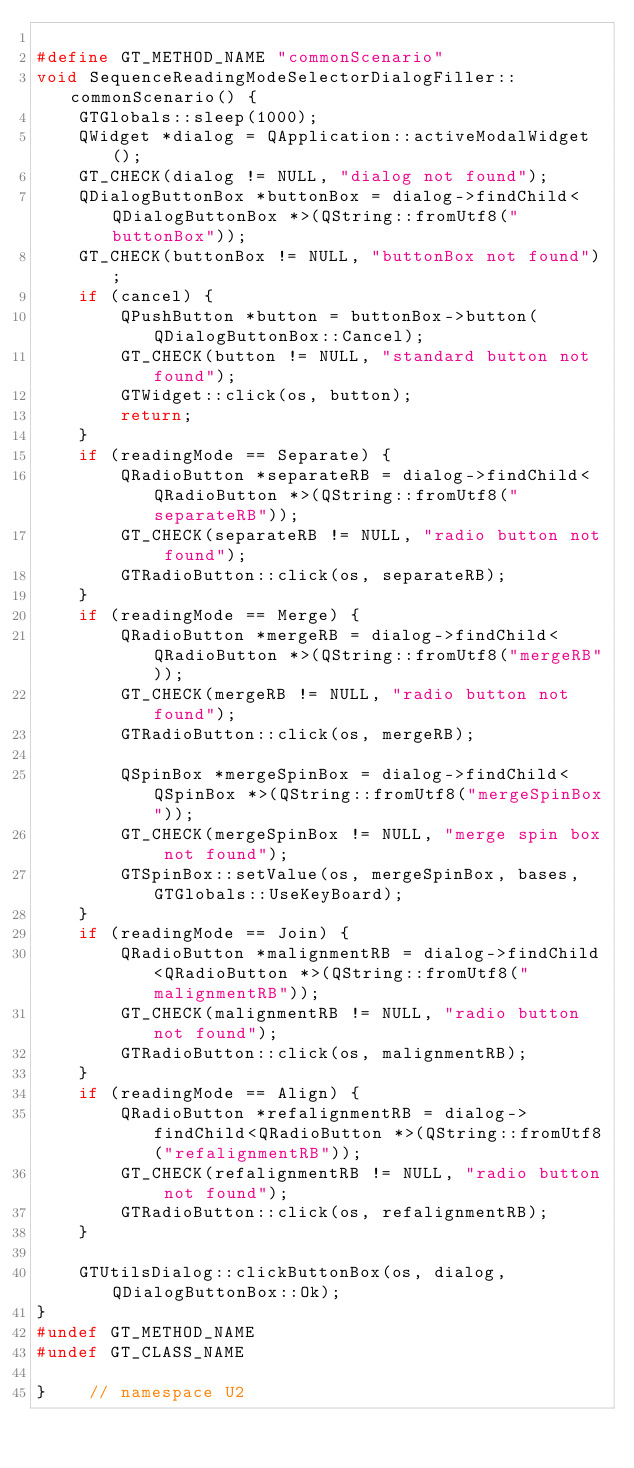Convert code to text. <code><loc_0><loc_0><loc_500><loc_500><_C++_>
#define GT_METHOD_NAME "commonScenario"
void SequenceReadingModeSelectorDialogFiller::commonScenario() {
    GTGlobals::sleep(1000);
    QWidget *dialog = QApplication::activeModalWidget();
    GT_CHECK(dialog != NULL, "dialog not found");
    QDialogButtonBox *buttonBox = dialog->findChild<QDialogButtonBox *>(QString::fromUtf8("buttonBox"));
    GT_CHECK(buttonBox != NULL, "buttonBox not found");
    if (cancel) {
        QPushButton *button = buttonBox->button(QDialogButtonBox::Cancel);
        GT_CHECK(button != NULL, "standard button not found");
        GTWidget::click(os, button);
        return;
    }
    if (readingMode == Separate) {
        QRadioButton *separateRB = dialog->findChild<QRadioButton *>(QString::fromUtf8("separateRB"));
        GT_CHECK(separateRB != NULL, "radio button not found");
        GTRadioButton::click(os, separateRB);
    }
    if (readingMode == Merge) {
        QRadioButton *mergeRB = dialog->findChild<QRadioButton *>(QString::fromUtf8("mergeRB"));
        GT_CHECK(mergeRB != NULL, "radio button not found");
        GTRadioButton::click(os, mergeRB);

        QSpinBox *mergeSpinBox = dialog->findChild<QSpinBox *>(QString::fromUtf8("mergeSpinBox"));
        GT_CHECK(mergeSpinBox != NULL, "merge spin box not found");
        GTSpinBox::setValue(os, mergeSpinBox, bases, GTGlobals::UseKeyBoard);
    }
    if (readingMode == Join) {
        QRadioButton *malignmentRB = dialog->findChild<QRadioButton *>(QString::fromUtf8("malignmentRB"));
        GT_CHECK(malignmentRB != NULL, "radio button not found");
        GTRadioButton::click(os, malignmentRB);
    }
    if (readingMode == Align) {
        QRadioButton *refalignmentRB = dialog->findChild<QRadioButton *>(QString::fromUtf8("refalignmentRB"));
        GT_CHECK(refalignmentRB != NULL, "radio button not found");
        GTRadioButton::click(os, refalignmentRB);
    }

    GTUtilsDialog::clickButtonBox(os, dialog, QDialogButtonBox::Ok);
}
#undef GT_METHOD_NAME
#undef GT_CLASS_NAME

}    // namespace U2
</code> 